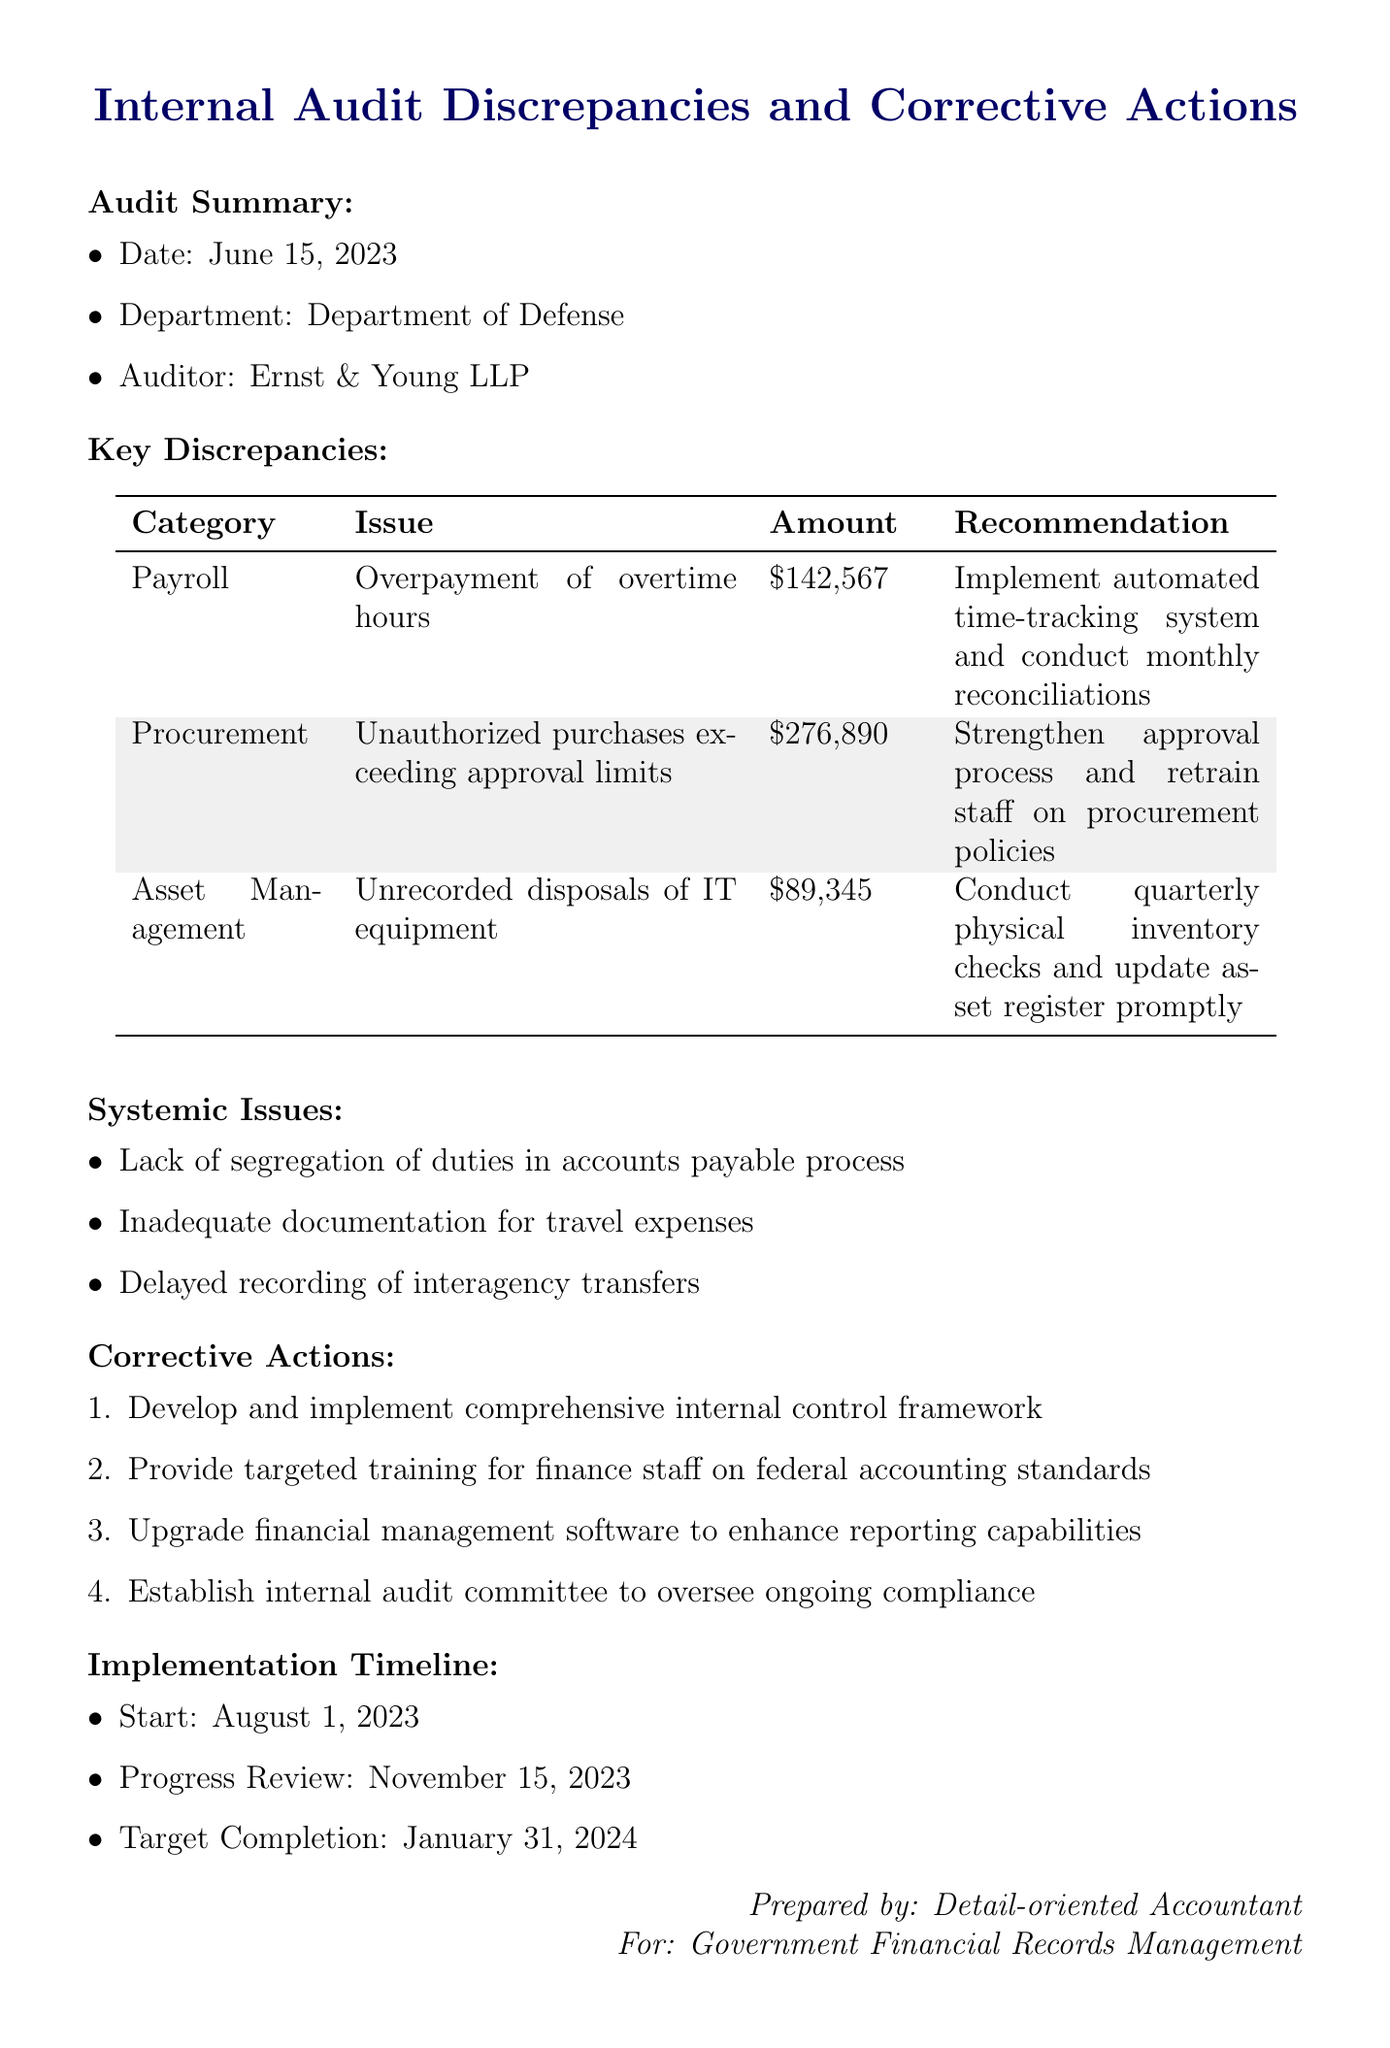What is the date of the audit? The date of the audit is mentioned in the audit summary section of the document.
Answer: June 15, 2023 Who conducted the audit? The auditor's name is provided in the audit summary section.
Answer: Ernst & Young LLP What is the total amount of overpayment found in the payroll category? The document specifies the amount related to overpayment of overtime hours in the payroll category.
Answer: $142,567 What systemic issue relates to travel expenses? One of the systemic issues listed in the document addresses documentation related to travel expenses.
Answer: Inadequate documentation for travel expenses What recommendation is given for unauthorized purchases? The recommendation for the procurement discrepancies is detailed in the key discrepancies section.
Answer: Strengthen approval process and retrain staff on procurement policies When is the progress review scheduled? The timeline section highlights important dates related to the implementation of corrective actions.
Answer: November 15, 2023 How many key discrepancies are listed? The document lists various discrepancies found during the audit.
Answer: Three What is one corrective action recommended in the document? The corrective actions are explicitly stated in a numbered list within the document.
Answer: Develop and implement comprehensive internal control framework What is the target completion date for the implementation of corrective actions? The timeline section provides the target date for completing all actions.
Answer: January 31, 2024 